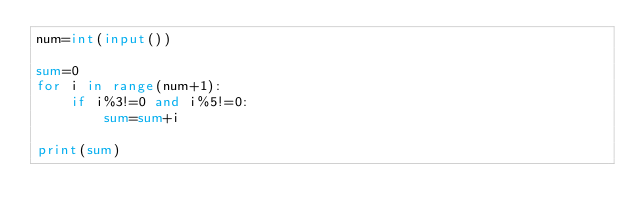Convert code to text. <code><loc_0><loc_0><loc_500><loc_500><_Python_>num=int(input())

sum=0
for i in range(num+1):
    if i%3!=0 and i%5!=0:
        sum=sum+i

print(sum)</code> 